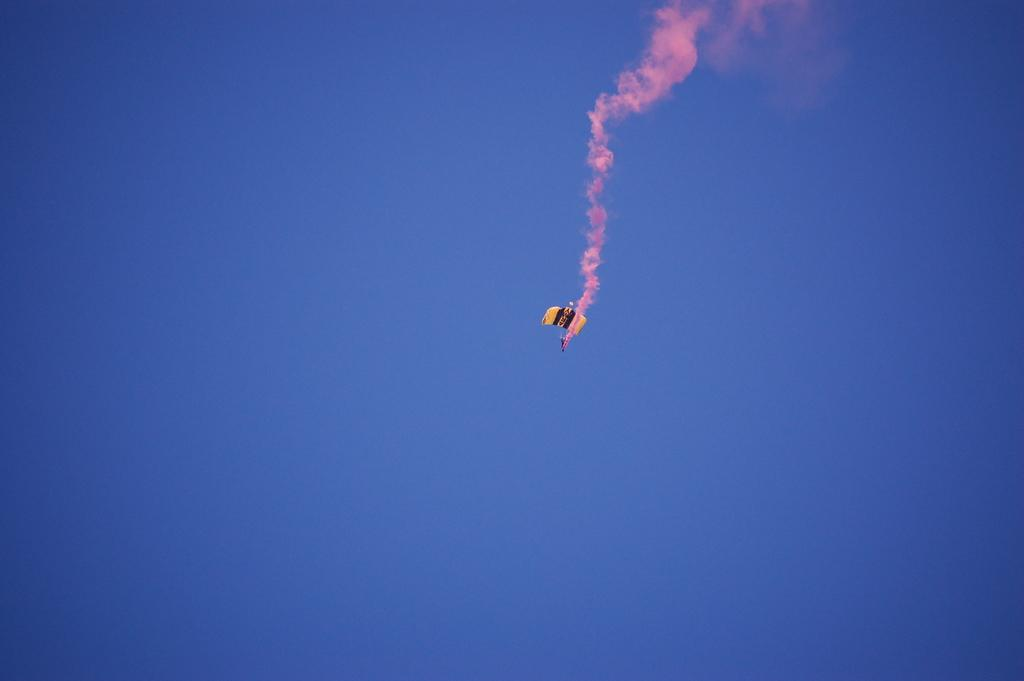What is the main object featured in the image? There is a parachute in the image. What can be seen in the sky in the image? There is color in the sky. How many bikes are parked in the room in the image? There is no room or bikes present in the image; it features a parachute and color in the sky. 